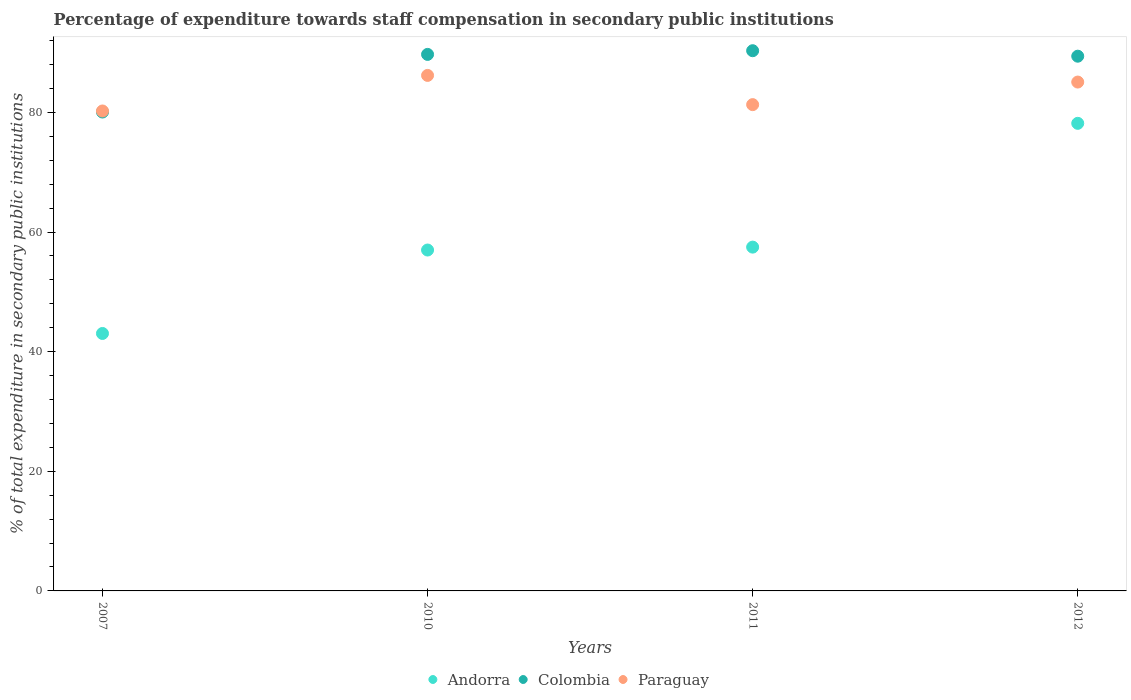How many different coloured dotlines are there?
Your answer should be compact. 3. Is the number of dotlines equal to the number of legend labels?
Keep it short and to the point. Yes. What is the percentage of expenditure towards staff compensation in Colombia in 2007?
Provide a succinct answer. 80.07. Across all years, what is the maximum percentage of expenditure towards staff compensation in Andorra?
Your answer should be very brief. 78.18. Across all years, what is the minimum percentage of expenditure towards staff compensation in Colombia?
Your answer should be compact. 80.07. What is the total percentage of expenditure towards staff compensation in Paraguay in the graph?
Ensure brevity in your answer.  332.81. What is the difference between the percentage of expenditure towards staff compensation in Colombia in 2011 and that in 2012?
Make the answer very short. 0.92. What is the difference between the percentage of expenditure towards staff compensation in Paraguay in 2011 and the percentage of expenditure towards staff compensation in Andorra in 2010?
Offer a terse response. 24.31. What is the average percentage of expenditure towards staff compensation in Paraguay per year?
Your answer should be compact. 83.2. In the year 2007, what is the difference between the percentage of expenditure towards staff compensation in Paraguay and percentage of expenditure towards staff compensation in Andorra?
Make the answer very short. 37.2. What is the ratio of the percentage of expenditure towards staff compensation in Andorra in 2007 to that in 2012?
Provide a short and direct response. 0.55. Is the percentage of expenditure towards staff compensation in Paraguay in 2011 less than that in 2012?
Your answer should be very brief. Yes. What is the difference between the highest and the second highest percentage of expenditure towards staff compensation in Andorra?
Make the answer very short. 20.7. What is the difference between the highest and the lowest percentage of expenditure towards staff compensation in Andorra?
Keep it short and to the point. 35.13. In how many years, is the percentage of expenditure towards staff compensation in Colombia greater than the average percentage of expenditure towards staff compensation in Colombia taken over all years?
Your answer should be very brief. 3. Is it the case that in every year, the sum of the percentage of expenditure towards staff compensation in Andorra and percentage of expenditure towards staff compensation in Paraguay  is greater than the percentage of expenditure towards staff compensation in Colombia?
Ensure brevity in your answer.  Yes. What is the difference between two consecutive major ticks on the Y-axis?
Offer a terse response. 20. Does the graph contain any zero values?
Your response must be concise. No. Does the graph contain grids?
Your answer should be compact. No. How are the legend labels stacked?
Your answer should be very brief. Horizontal. What is the title of the graph?
Make the answer very short. Percentage of expenditure towards staff compensation in secondary public institutions. What is the label or title of the X-axis?
Your response must be concise. Years. What is the label or title of the Y-axis?
Keep it short and to the point. % of total expenditure in secondary public institutions. What is the % of total expenditure in secondary public institutions of Andorra in 2007?
Your answer should be compact. 43.04. What is the % of total expenditure in secondary public institutions in Colombia in 2007?
Offer a very short reply. 80.07. What is the % of total expenditure in secondary public institutions in Paraguay in 2007?
Your answer should be very brief. 80.24. What is the % of total expenditure in secondary public institutions of Andorra in 2010?
Provide a short and direct response. 56.99. What is the % of total expenditure in secondary public institutions in Colombia in 2010?
Make the answer very short. 89.7. What is the % of total expenditure in secondary public institutions of Paraguay in 2010?
Your response must be concise. 86.19. What is the % of total expenditure in secondary public institutions of Andorra in 2011?
Give a very brief answer. 57.48. What is the % of total expenditure in secondary public institutions in Colombia in 2011?
Provide a short and direct response. 90.32. What is the % of total expenditure in secondary public institutions of Paraguay in 2011?
Provide a succinct answer. 81.3. What is the % of total expenditure in secondary public institutions of Andorra in 2012?
Your answer should be compact. 78.18. What is the % of total expenditure in secondary public institutions in Colombia in 2012?
Keep it short and to the point. 89.4. What is the % of total expenditure in secondary public institutions in Paraguay in 2012?
Your answer should be very brief. 85.08. Across all years, what is the maximum % of total expenditure in secondary public institutions of Andorra?
Offer a very short reply. 78.18. Across all years, what is the maximum % of total expenditure in secondary public institutions in Colombia?
Provide a succinct answer. 90.32. Across all years, what is the maximum % of total expenditure in secondary public institutions in Paraguay?
Provide a short and direct response. 86.19. Across all years, what is the minimum % of total expenditure in secondary public institutions in Andorra?
Make the answer very short. 43.04. Across all years, what is the minimum % of total expenditure in secondary public institutions in Colombia?
Your response must be concise. 80.07. Across all years, what is the minimum % of total expenditure in secondary public institutions in Paraguay?
Provide a short and direct response. 80.24. What is the total % of total expenditure in secondary public institutions in Andorra in the graph?
Ensure brevity in your answer.  235.69. What is the total % of total expenditure in secondary public institutions of Colombia in the graph?
Your answer should be very brief. 349.48. What is the total % of total expenditure in secondary public institutions in Paraguay in the graph?
Ensure brevity in your answer.  332.81. What is the difference between the % of total expenditure in secondary public institutions in Andorra in 2007 and that in 2010?
Offer a terse response. -13.95. What is the difference between the % of total expenditure in secondary public institutions in Colombia in 2007 and that in 2010?
Offer a terse response. -9.64. What is the difference between the % of total expenditure in secondary public institutions of Paraguay in 2007 and that in 2010?
Make the answer very short. -5.95. What is the difference between the % of total expenditure in secondary public institutions in Andorra in 2007 and that in 2011?
Offer a terse response. -14.44. What is the difference between the % of total expenditure in secondary public institutions of Colombia in 2007 and that in 2011?
Your answer should be compact. -10.25. What is the difference between the % of total expenditure in secondary public institutions of Paraguay in 2007 and that in 2011?
Offer a very short reply. -1.06. What is the difference between the % of total expenditure in secondary public institutions in Andorra in 2007 and that in 2012?
Give a very brief answer. -35.13. What is the difference between the % of total expenditure in secondary public institutions of Colombia in 2007 and that in 2012?
Offer a terse response. -9.33. What is the difference between the % of total expenditure in secondary public institutions of Paraguay in 2007 and that in 2012?
Your answer should be compact. -4.84. What is the difference between the % of total expenditure in secondary public institutions in Andorra in 2010 and that in 2011?
Your answer should be compact. -0.49. What is the difference between the % of total expenditure in secondary public institutions in Colombia in 2010 and that in 2011?
Your answer should be very brief. -0.62. What is the difference between the % of total expenditure in secondary public institutions of Paraguay in 2010 and that in 2011?
Your answer should be compact. 4.89. What is the difference between the % of total expenditure in secondary public institutions in Andorra in 2010 and that in 2012?
Offer a terse response. -21.18. What is the difference between the % of total expenditure in secondary public institutions of Colombia in 2010 and that in 2012?
Provide a short and direct response. 0.3. What is the difference between the % of total expenditure in secondary public institutions of Paraguay in 2010 and that in 2012?
Offer a terse response. 1.11. What is the difference between the % of total expenditure in secondary public institutions of Andorra in 2011 and that in 2012?
Make the answer very short. -20.7. What is the difference between the % of total expenditure in secondary public institutions of Colombia in 2011 and that in 2012?
Make the answer very short. 0.92. What is the difference between the % of total expenditure in secondary public institutions of Paraguay in 2011 and that in 2012?
Your response must be concise. -3.78. What is the difference between the % of total expenditure in secondary public institutions in Andorra in 2007 and the % of total expenditure in secondary public institutions in Colombia in 2010?
Offer a terse response. -46.66. What is the difference between the % of total expenditure in secondary public institutions of Andorra in 2007 and the % of total expenditure in secondary public institutions of Paraguay in 2010?
Your answer should be very brief. -43.15. What is the difference between the % of total expenditure in secondary public institutions in Colombia in 2007 and the % of total expenditure in secondary public institutions in Paraguay in 2010?
Provide a succinct answer. -6.12. What is the difference between the % of total expenditure in secondary public institutions in Andorra in 2007 and the % of total expenditure in secondary public institutions in Colombia in 2011?
Make the answer very short. -47.27. What is the difference between the % of total expenditure in secondary public institutions in Andorra in 2007 and the % of total expenditure in secondary public institutions in Paraguay in 2011?
Ensure brevity in your answer.  -38.26. What is the difference between the % of total expenditure in secondary public institutions of Colombia in 2007 and the % of total expenditure in secondary public institutions of Paraguay in 2011?
Offer a terse response. -1.24. What is the difference between the % of total expenditure in secondary public institutions in Andorra in 2007 and the % of total expenditure in secondary public institutions in Colombia in 2012?
Give a very brief answer. -46.36. What is the difference between the % of total expenditure in secondary public institutions in Andorra in 2007 and the % of total expenditure in secondary public institutions in Paraguay in 2012?
Your response must be concise. -42.03. What is the difference between the % of total expenditure in secondary public institutions of Colombia in 2007 and the % of total expenditure in secondary public institutions of Paraguay in 2012?
Provide a succinct answer. -5.01. What is the difference between the % of total expenditure in secondary public institutions in Andorra in 2010 and the % of total expenditure in secondary public institutions in Colombia in 2011?
Your answer should be compact. -33.32. What is the difference between the % of total expenditure in secondary public institutions of Andorra in 2010 and the % of total expenditure in secondary public institutions of Paraguay in 2011?
Your answer should be very brief. -24.31. What is the difference between the % of total expenditure in secondary public institutions of Colombia in 2010 and the % of total expenditure in secondary public institutions of Paraguay in 2011?
Provide a succinct answer. 8.4. What is the difference between the % of total expenditure in secondary public institutions in Andorra in 2010 and the % of total expenditure in secondary public institutions in Colombia in 2012?
Provide a succinct answer. -32.41. What is the difference between the % of total expenditure in secondary public institutions in Andorra in 2010 and the % of total expenditure in secondary public institutions in Paraguay in 2012?
Offer a terse response. -28.08. What is the difference between the % of total expenditure in secondary public institutions in Colombia in 2010 and the % of total expenditure in secondary public institutions in Paraguay in 2012?
Offer a terse response. 4.62. What is the difference between the % of total expenditure in secondary public institutions in Andorra in 2011 and the % of total expenditure in secondary public institutions in Colombia in 2012?
Give a very brief answer. -31.92. What is the difference between the % of total expenditure in secondary public institutions in Andorra in 2011 and the % of total expenditure in secondary public institutions in Paraguay in 2012?
Provide a short and direct response. -27.6. What is the difference between the % of total expenditure in secondary public institutions of Colombia in 2011 and the % of total expenditure in secondary public institutions of Paraguay in 2012?
Provide a succinct answer. 5.24. What is the average % of total expenditure in secondary public institutions of Andorra per year?
Offer a terse response. 58.92. What is the average % of total expenditure in secondary public institutions in Colombia per year?
Offer a very short reply. 87.37. What is the average % of total expenditure in secondary public institutions of Paraguay per year?
Your response must be concise. 83.2. In the year 2007, what is the difference between the % of total expenditure in secondary public institutions in Andorra and % of total expenditure in secondary public institutions in Colombia?
Provide a short and direct response. -37.02. In the year 2007, what is the difference between the % of total expenditure in secondary public institutions of Andorra and % of total expenditure in secondary public institutions of Paraguay?
Offer a very short reply. -37.2. In the year 2007, what is the difference between the % of total expenditure in secondary public institutions in Colombia and % of total expenditure in secondary public institutions in Paraguay?
Your response must be concise. -0.18. In the year 2010, what is the difference between the % of total expenditure in secondary public institutions in Andorra and % of total expenditure in secondary public institutions in Colombia?
Your response must be concise. -32.71. In the year 2010, what is the difference between the % of total expenditure in secondary public institutions in Andorra and % of total expenditure in secondary public institutions in Paraguay?
Your answer should be compact. -29.19. In the year 2010, what is the difference between the % of total expenditure in secondary public institutions of Colombia and % of total expenditure in secondary public institutions of Paraguay?
Provide a succinct answer. 3.51. In the year 2011, what is the difference between the % of total expenditure in secondary public institutions in Andorra and % of total expenditure in secondary public institutions in Colombia?
Your response must be concise. -32.84. In the year 2011, what is the difference between the % of total expenditure in secondary public institutions in Andorra and % of total expenditure in secondary public institutions in Paraguay?
Give a very brief answer. -23.82. In the year 2011, what is the difference between the % of total expenditure in secondary public institutions of Colombia and % of total expenditure in secondary public institutions of Paraguay?
Make the answer very short. 9.02. In the year 2012, what is the difference between the % of total expenditure in secondary public institutions in Andorra and % of total expenditure in secondary public institutions in Colombia?
Your answer should be compact. -11.22. In the year 2012, what is the difference between the % of total expenditure in secondary public institutions in Andorra and % of total expenditure in secondary public institutions in Paraguay?
Provide a succinct answer. -6.9. In the year 2012, what is the difference between the % of total expenditure in secondary public institutions in Colombia and % of total expenditure in secondary public institutions in Paraguay?
Ensure brevity in your answer.  4.32. What is the ratio of the % of total expenditure in secondary public institutions of Andorra in 2007 to that in 2010?
Make the answer very short. 0.76. What is the ratio of the % of total expenditure in secondary public institutions of Colombia in 2007 to that in 2010?
Your answer should be very brief. 0.89. What is the ratio of the % of total expenditure in secondary public institutions in Andorra in 2007 to that in 2011?
Ensure brevity in your answer.  0.75. What is the ratio of the % of total expenditure in secondary public institutions in Colombia in 2007 to that in 2011?
Your answer should be compact. 0.89. What is the ratio of the % of total expenditure in secondary public institutions in Paraguay in 2007 to that in 2011?
Offer a very short reply. 0.99. What is the ratio of the % of total expenditure in secondary public institutions in Andorra in 2007 to that in 2012?
Offer a terse response. 0.55. What is the ratio of the % of total expenditure in secondary public institutions of Colombia in 2007 to that in 2012?
Offer a very short reply. 0.9. What is the ratio of the % of total expenditure in secondary public institutions in Paraguay in 2007 to that in 2012?
Your answer should be compact. 0.94. What is the ratio of the % of total expenditure in secondary public institutions of Paraguay in 2010 to that in 2011?
Your answer should be compact. 1.06. What is the ratio of the % of total expenditure in secondary public institutions in Andorra in 2010 to that in 2012?
Ensure brevity in your answer.  0.73. What is the ratio of the % of total expenditure in secondary public institutions in Paraguay in 2010 to that in 2012?
Provide a succinct answer. 1.01. What is the ratio of the % of total expenditure in secondary public institutions of Andorra in 2011 to that in 2012?
Offer a very short reply. 0.74. What is the ratio of the % of total expenditure in secondary public institutions in Colombia in 2011 to that in 2012?
Make the answer very short. 1.01. What is the ratio of the % of total expenditure in secondary public institutions of Paraguay in 2011 to that in 2012?
Your answer should be compact. 0.96. What is the difference between the highest and the second highest % of total expenditure in secondary public institutions of Andorra?
Provide a succinct answer. 20.7. What is the difference between the highest and the second highest % of total expenditure in secondary public institutions of Colombia?
Your response must be concise. 0.62. What is the difference between the highest and the second highest % of total expenditure in secondary public institutions of Paraguay?
Make the answer very short. 1.11. What is the difference between the highest and the lowest % of total expenditure in secondary public institutions in Andorra?
Offer a very short reply. 35.13. What is the difference between the highest and the lowest % of total expenditure in secondary public institutions in Colombia?
Your response must be concise. 10.25. What is the difference between the highest and the lowest % of total expenditure in secondary public institutions in Paraguay?
Give a very brief answer. 5.95. 